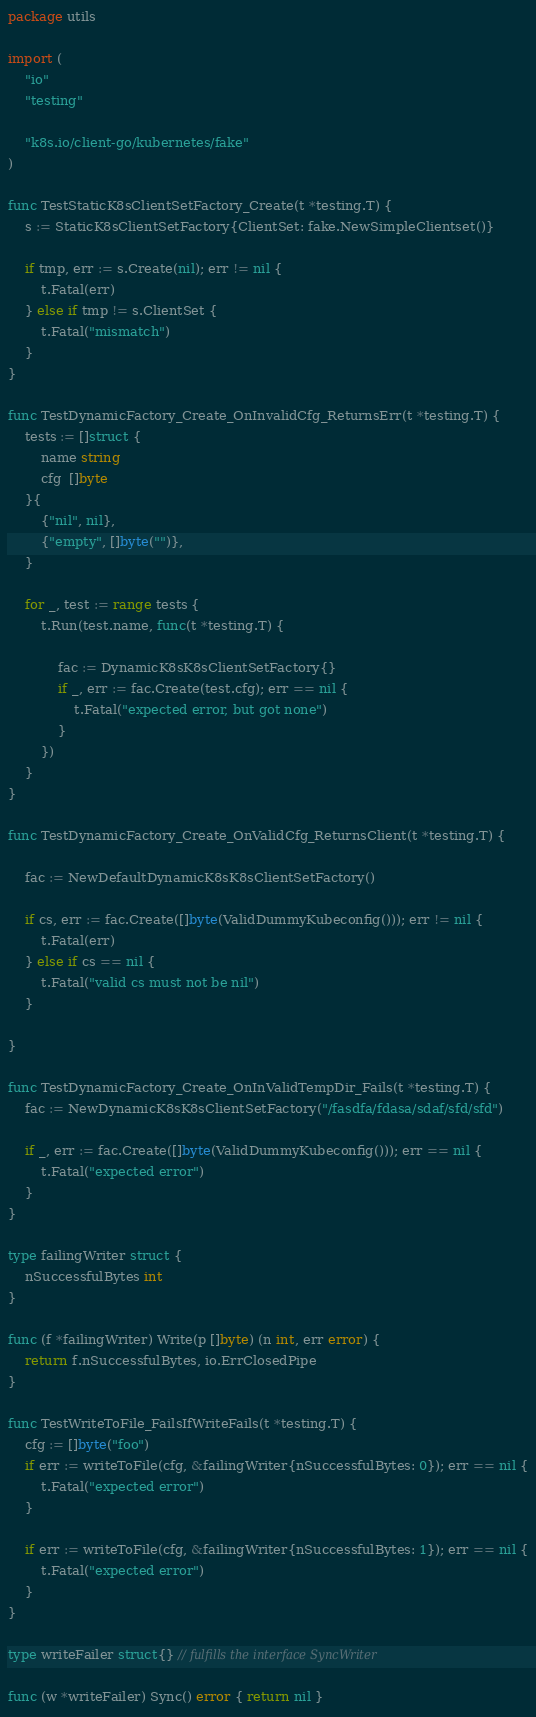<code> <loc_0><loc_0><loc_500><loc_500><_Go_>package utils

import (
	"io"
	"testing"

	"k8s.io/client-go/kubernetes/fake"
)

func TestStaticK8sClientSetFactory_Create(t *testing.T) {
	s := StaticK8sClientSetFactory{ClientSet: fake.NewSimpleClientset()}

	if tmp, err := s.Create(nil); err != nil {
		t.Fatal(err)
	} else if tmp != s.ClientSet {
		t.Fatal("mismatch")
	}
}

func TestDynamicFactory_Create_OnInvalidCfg_ReturnsErr(t *testing.T) {
	tests := []struct {
		name string
		cfg  []byte
	}{
		{"nil", nil},
		{"empty", []byte("")},
	}

	for _, test := range tests {
		t.Run(test.name, func(t *testing.T) {

			fac := DynamicK8sK8sClientSetFactory{}
			if _, err := fac.Create(test.cfg); err == nil {
				t.Fatal("expected error, but got none")
			}
		})
	}
}

func TestDynamicFactory_Create_OnValidCfg_ReturnsClient(t *testing.T) {

	fac := NewDefaultDynamicK8sK8sClientSetFactory()

	if cs, err := fac.Create([]byte(ValidDummyKubeconfig())); err != nil {
		t.Fatal(err)
	} else if cs == nil {
		t.Fatal("valid cs must not be nil")
	}

}

func TestDynamicFactory_Create_OnInValidTempDir_Fails(t *testing.T) {
	fac := NewDynamicK8sK8sClientSetFactory("/fasdfa/fdasa/sdaf/sfd/sfd")

	if _, err := fac.Create([]byte(ValidDummyKubeconfig())); err == nil {
		t.Fatal("expected error")
	}
}

type failingWriter struct {
	nSuccessfulBytes int
}

func (f *failingWriter) Write(p []byte) (n int, err error) {
	return f.nSuccessfulBytes, io.ErrClosedPipe
}

func TestWriteToFile_FailsIfWriteFails(t *testing.T) {
	cfg := []byte("foo")
	if err := writeToFile(cfg, &failingWriter{nSuccessfulBytes: 0}); err == nil {
		t.Fatal("expected error")
	}

	if err := writeToFile(cfg, &failingWriter{nSuccessfulBytes: 1}); err == nil {
		t.Fatal("expected error")
	}
}

type writeFailer struct{} // fulfills the interface SyncWriter

func (w *writeFailer) Sync() error { return nil }</code> 